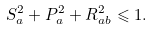Convert formula to latex. <formula><loc_0><loc_0><loc_500><loc_500>S _ { a } ^ { 2 } + P _ { a } ^ { 2 } + R _ { a b } ^ { 2 } \leqslant 1 .</formula> 